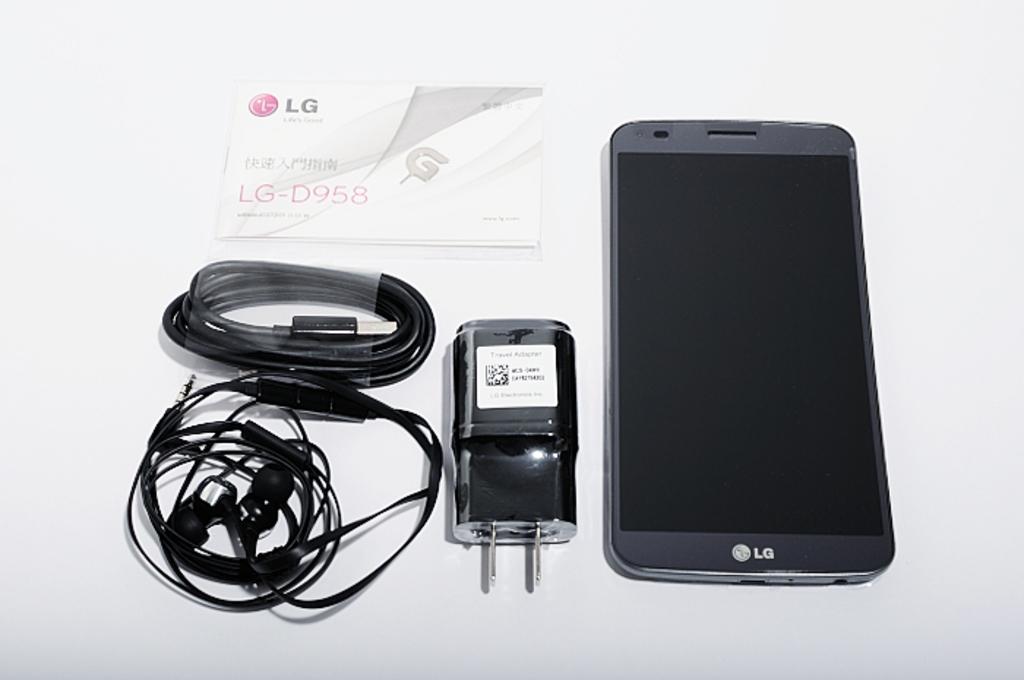Is that an lg-d958 phone?
Offer a terse response. Yes. What is the brand of this smartphone?
Provide a short and direct response. Lg. 